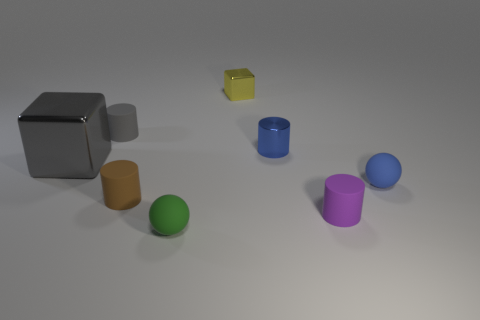Add 2 purple things. How many objects exist? 10 Subtract all small rubber cylinders. How many cylinders are left? 1 Subtract 4 cylinders. How many cylinders are left? 0 Subtract all green spheres. How many spheres are left? 1 Subtract all brown balls. Subtract all yellow blocks. How many balls are left? 2 Subtract 0 red balls. How many objects are left? 8 Subtract all red cubes. How many purple balls are left? 0 Subtract all small balls. Subtract all metal cubes. How many objects are left? 4 Add 3 gray cylinders. How many gray cylinders are left? 4 Add 4 big green objects. How many big green objects exist? 4 